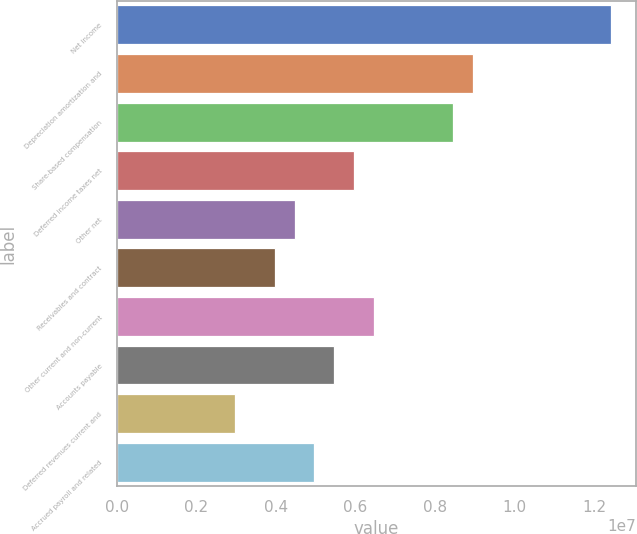Convert chart to OTSL. <chart><loc_0><loc_0><loc_500><loc_500><bar_chart><fcel>Net income<fcel>Depreciation amortization and<fcel>Share-based compensation<fcel>Deferred income taxes net<fcel>Other net<fcel>Receivables and contract<fcel>Other current and non-current<fcel>Accounts payable<fcel>Deferred revenues current and<fcel>Accrued payroll and related<nl><fcel>1.24294e+07<fcel>8.94977e+06<fcel>8.45268e+06<fcel>5.96722e+06<fcel>4.47595e+06<fcel>3.97886e+06<fcel>6.46431e+06<fcel>5.47013e+06<fcel>2.98467e+06<fcel>4.97304e+06<nl></chart> 